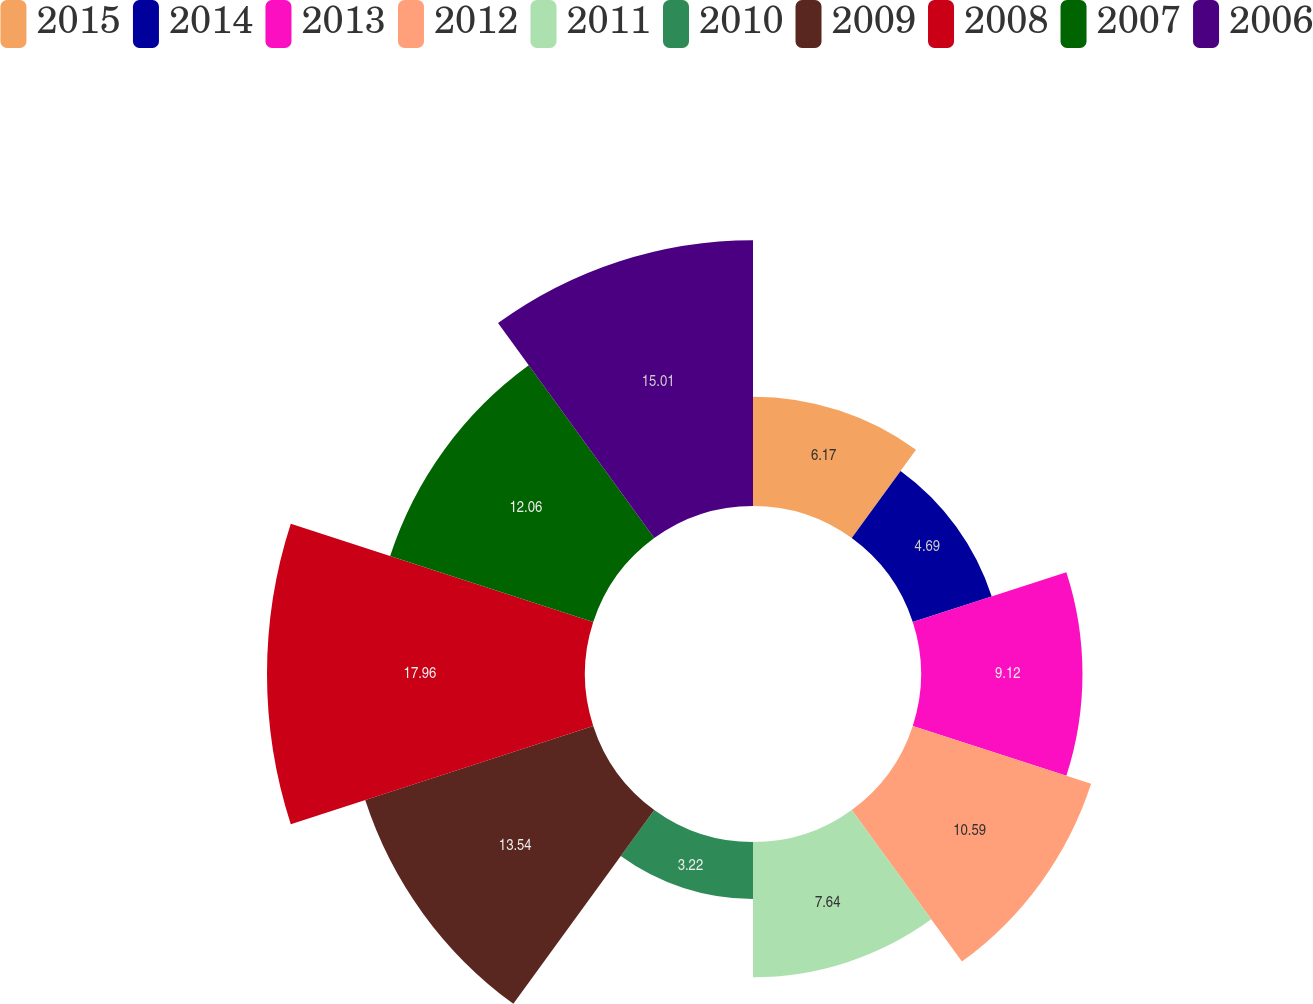<chart> <loc_0><loc_0><loc_500><loc_500><pie_chart><fcel>2015<fcel>2014<fcel>2013<fcel>2012<fcel>2011<fcel>2010<fcel>2009<fcel>2008<fcel>2007<fcel>2006<nl><fcel>6.17%<fcel>4.69%<fcel>9.12%<fcel>10.59%<fcel>7.64%<fcel>3.22%<fcel>13.54%<fcel>17.96%<fcel>12.06%<fcel>15.01%<nl></chart> 